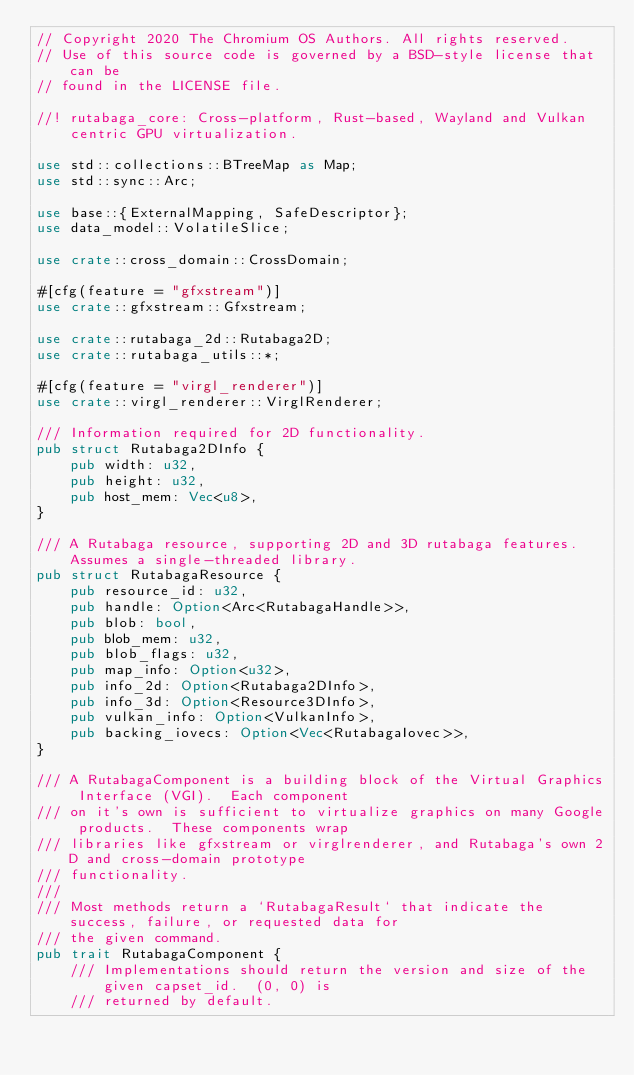<code> <loc_0><loc_0><loc_500><loc_500><_Rust_>// Copyright 2020 The Chromium OS Authors. All rights reserved.
// Use of this source code is governed by a BSD-style license that can be
// found in the LICENSE file.

//! rutabaga_core: Cross-platform, Rust-based, Wayland and Vulkan centric GPU virtualization.

use std::collections::BTreeMap as Map;
use std::sync::Arc;

use base::{ExternalMapping, SafeDescriptor};
use data_model::VolatileSlice;

use crate::cross_domain::CrossDomain;

#[cfg(feature = "gfxstream")]
use crate::gfxstream::Gfxstream;

use crate::rutabaga_2d::Rutabaga2D;
use crate::rutabaga_utils::*;

#[cfg(feature = "virgl_renderer")]
use crate::virgl_renderer::VirglRenderer;

/// Information required for 2D functionality.
pub struct Rutabaga2DInfo {
    pub width: u32,
    pub height: u32,
    pub host_mem: Vec<u8>,
}

/// A Rutabaga resource, supporting 2D and 3D rutabaga features.  Assumes a single-threaded library.
pub struct RutabagaResource {
    pub resource_id: u32,
    pub handle: Option<Arc<RutabagaHandle>>,
    pub blob: bool,
    pub blob_mem: u32,
    pub blob_flags: u32,
    pub map_info: Option<u32>,
    pub info_2d: Option<Rutabaga2DInfo>,
    pub info_3d: Option<Resource3DInfo>,
    pub vulkan_info: Option<VulkanInfo>,
    pub backing_iovecs: Option<Vec<RutabagaIovec>>,
}

/// A RutabagaComponent is a building block of the Virtual Graphics Interface (VGI).  Each component
/// on it's own is sufficient to virtualize graphics on many Google products.  These components wrap
/// libraries like gfxstream or virglrenderer, and Rutabaga's own 2D and cross-domain prototype
/// functionality.
///
/// Most methods return a `RutabagaResult` that indicate the success, failure, or requested data for
/// the given command.
pub trait RutabagaComponent {
    /// Implementations should return the version and size of the given capset_id.  (0, 0) is
    /// returned by default.</code> 